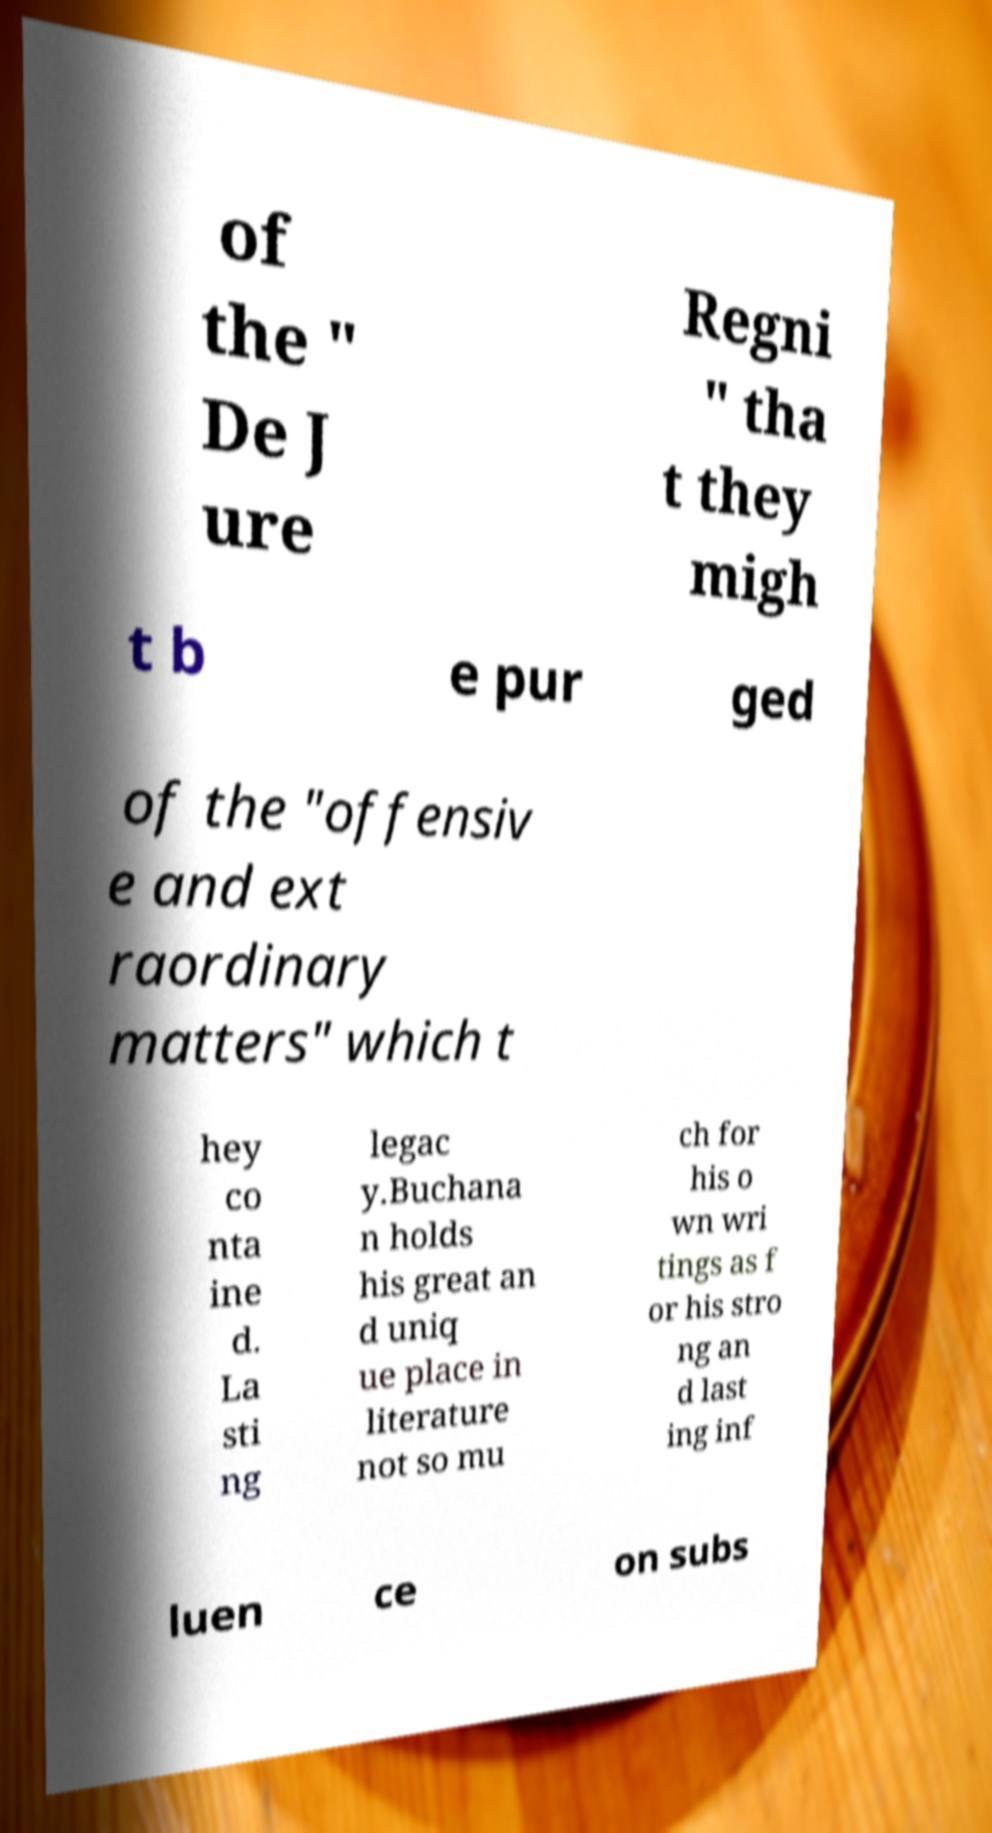Can you read and provide the text displayed in the image?This photo seems to have some interesting text. Can you extract and type it out for me? of the " De J ure Regni " tha t they migh t b e pur ged of the "offensiv e and ext raordinary matters" which t hey co nta ine d. La sti ng legac y.Buchana n holds his great an d uniq ue place in literature not so mu ch for his o wn wri tings as f or his stro ng an d last ing inf luen ce on subs 